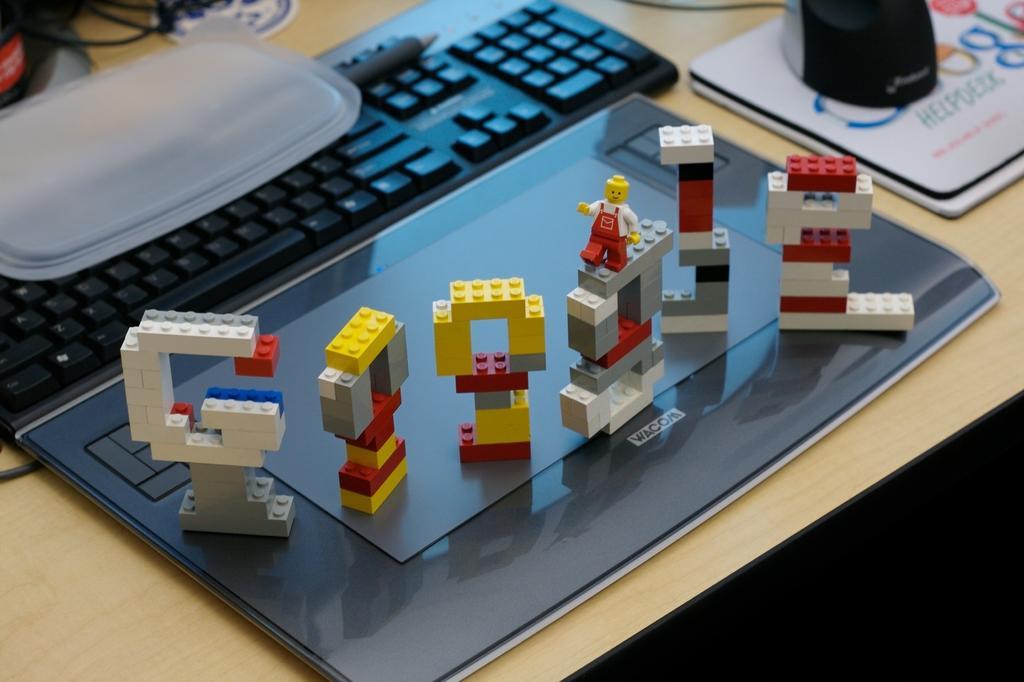Please provide a concise description of this image. In this image we can see some toys on the surface and we can also see the keyboard, wire and wooden object. 